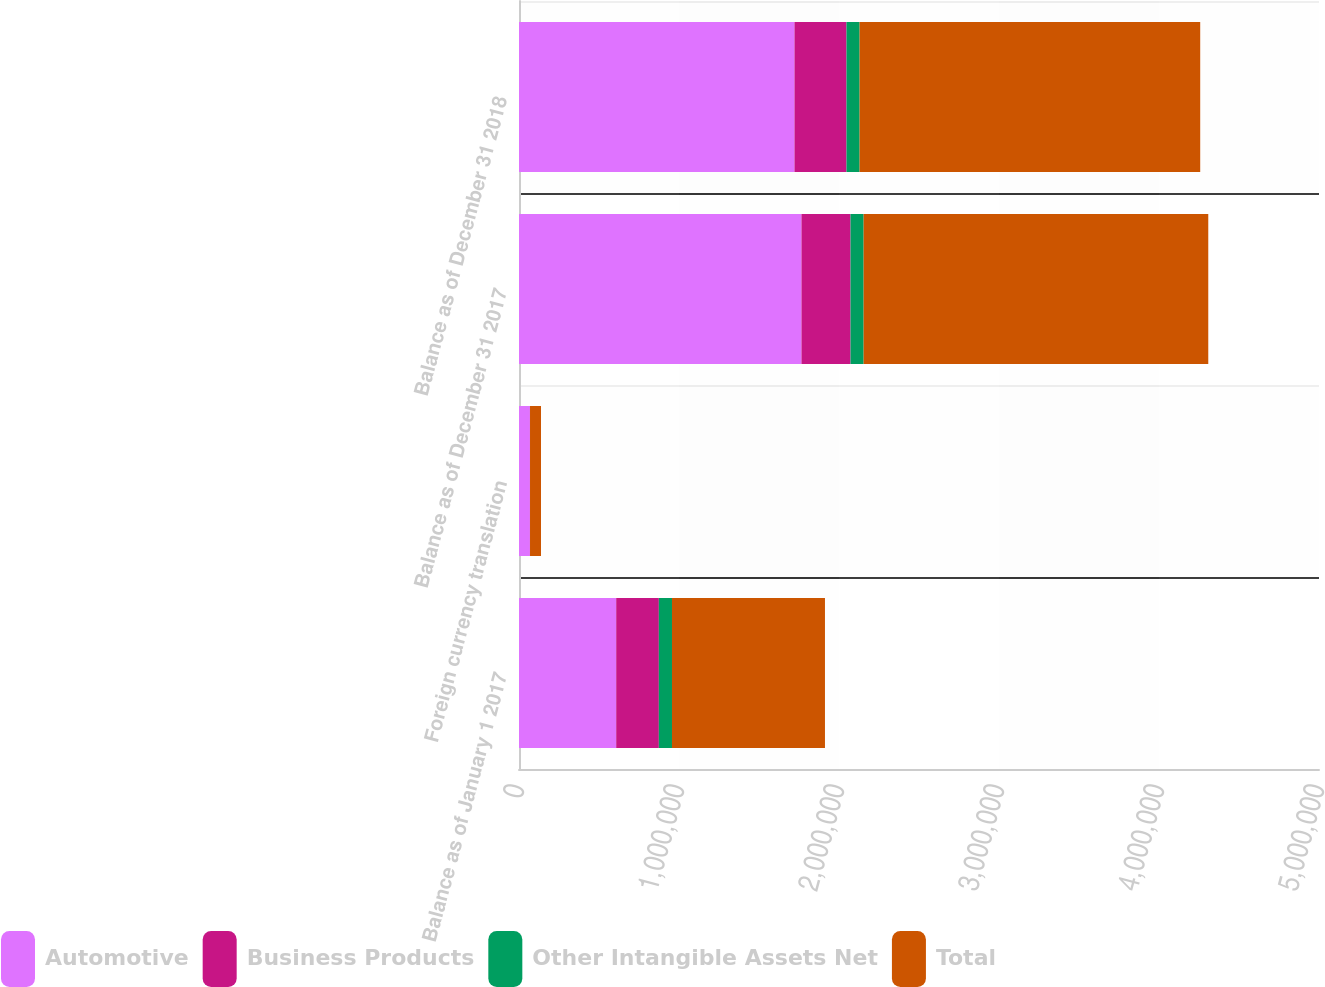<chart> <loc_0><loc_0><loc_500><loc_500><stacked_bar_chart><ecel><fcel>Balance as of January 1 2017<fcel>Foreign currency translation<fcel>Balance as of December 31 2017<fcel>Balance as of December 31 2018<nl><fcel>Automotive<fcel>607558<fcel>68183<fcel>1.76551e+06<fcel>1.72182e+06<nl><fcel>Business Products<fcel>266495<fcel>577<fcel>306491<fcel>324997<nl><fcel>Other Intangible Assets Net<fcel>82100<fcel>111<fcel>81989<fcel>81956<nl><fcel>Total<fcel>956153<fcel>68649<fcel>2.15399e+06<fcel>2.12878e+06<nl></chart> 